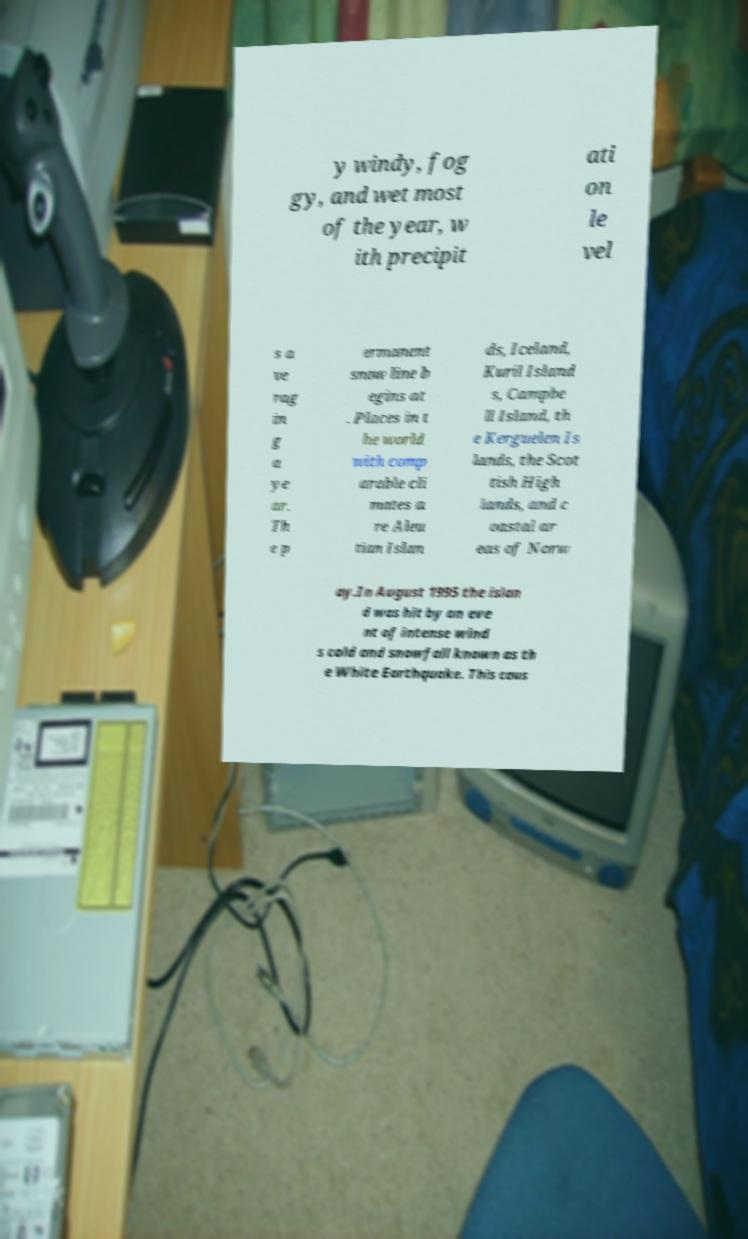Could you extract and type out the text from this image? y windy, fog gy, and wet most of the year, w ith precipit ati on le vel s a ve rag in g a ye ar. Th e p ermanent snow line b egins at . Places in t he world with comp arable cli mates a re Aleu tian Islan ds, Iceland, Kuril Island s, Campbe ll Island, th e Kerguelen Is lands, the Scot tish High lands, and c oastal ar eas of Norw ay.In August 1995 the islan d was hit by an eve nt of intense wind s cold and snowfall known as th e White Earthquake. This caus 